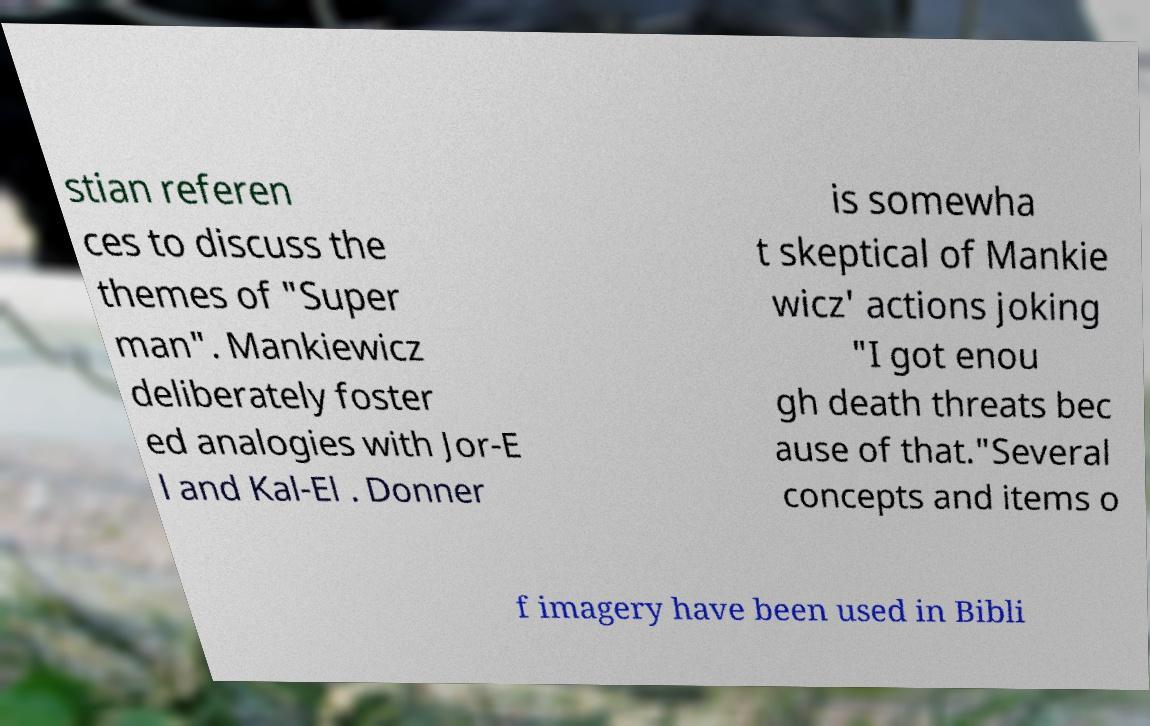For documentation purposes, I need the text within this image transcribed. Could you provide that? stian referen ces to discuss the themes of "Super man". Mankiewicz deliberately foster ed analogies with Jor-E l and Kal-El . Donner is somewha t skeptical of Mankie wicz' actions joking "I got enou gh death threats bec ause of that."Several concepts and items o f imagery have been used in Bibli 